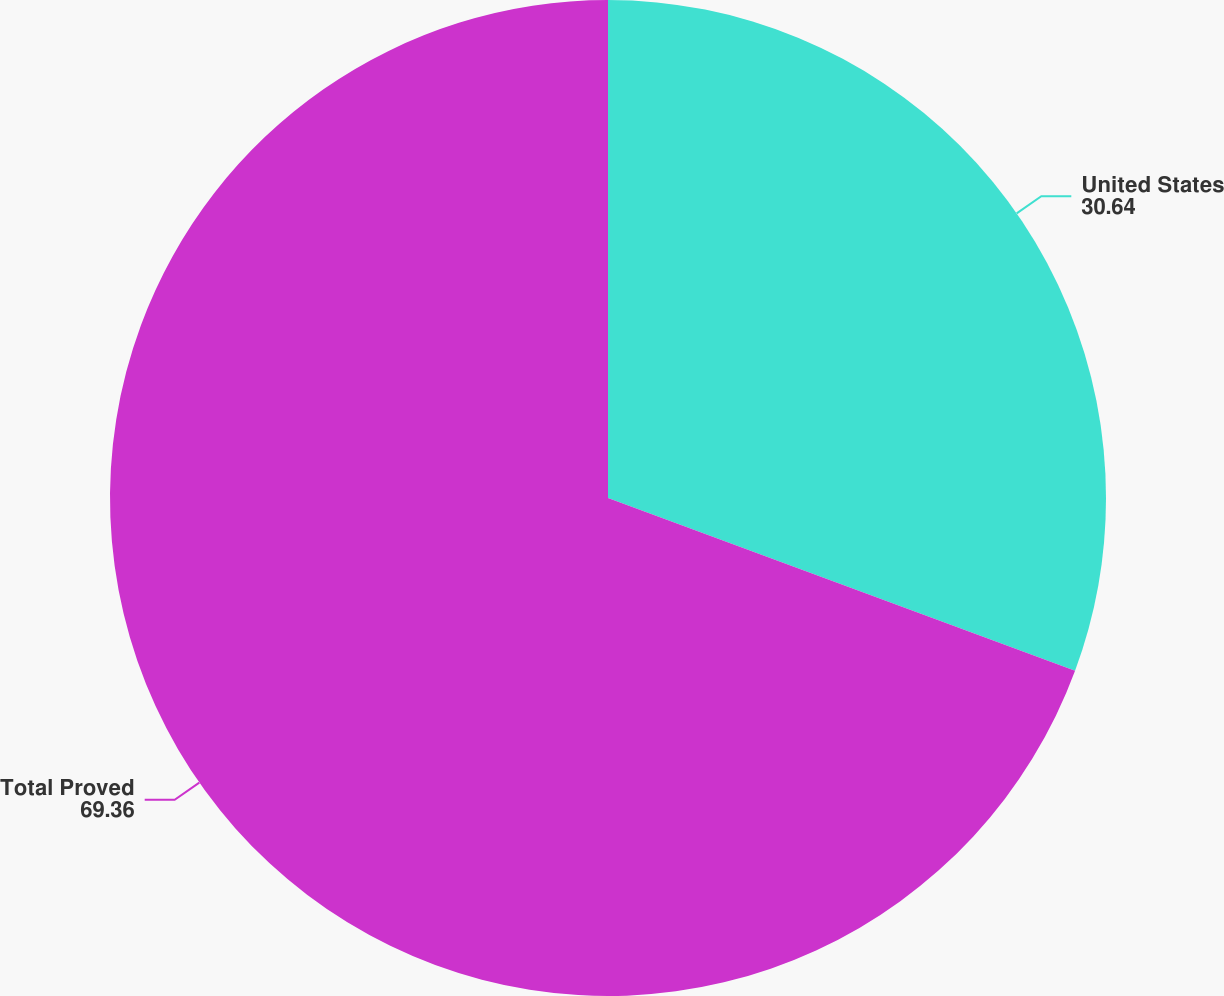Convert chart. <chart><loc_0><loc_0><loc_500><loc_500><pie_chart><fcel>United States<fcel>Total Proved<nl><fcel>30.64%<fcel>69.36%<nl></chart> 